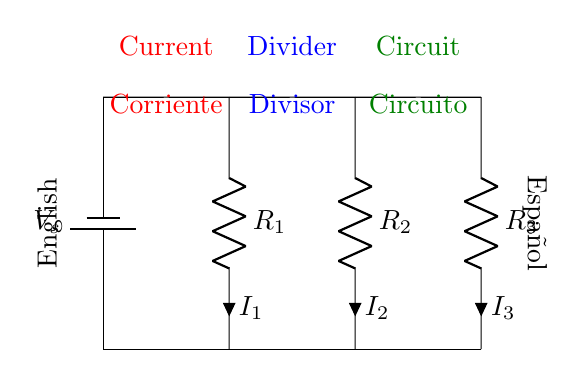What is the total number of resistors in the circuit? There are three resistors labeled R1, R2, and R3. Therefore, we count them directly from the diagram.
Answer: 3 What does the label V_s represent? V_s is the voltage source in the diagram, which provides electric potential to the circuit. It's labeled as "V_s," standing for the source voltage.
Answer: Voltage source What do the labels I1, I2, and I3 represent? I1, I2, and I3 represent the currents flowing through resistors R1, R2, and R3, respectively. These labels are placed adjacent to each resistor, indicating the current through each component.
Answer: Currents Which resistor would have the highest current if they all have the same resistance? If all resistors have the same resistance, the current will divide equally. In this case, I1, I2, and I3 would be equal, leading to no single resistor having the highest current.
Answer: No single highest How does the current divide in a current divider circuit? In a current divider circuit, the total current enters the junction and is divided inversely proportional to the resistance of each resistor. The resistors with lower resistance will have a higher current.
Answer: Inversely proportional to resistance If R1 is removed from the circuit, what happens to I2 and I3? Removing R1 would change the distribution of the total current. The current that was flowing through R1 will now flow through R2 and R3, causing their currents to increase while keeping the total current constant.
Answer: I2 and I3 increase What is the purpose of a current divider circuit? A current divider circuit is used to distribute a single input current into multiple output currents proportionally, based on the resistances in the parallel branches.
Answer: Distributing current proportionally 